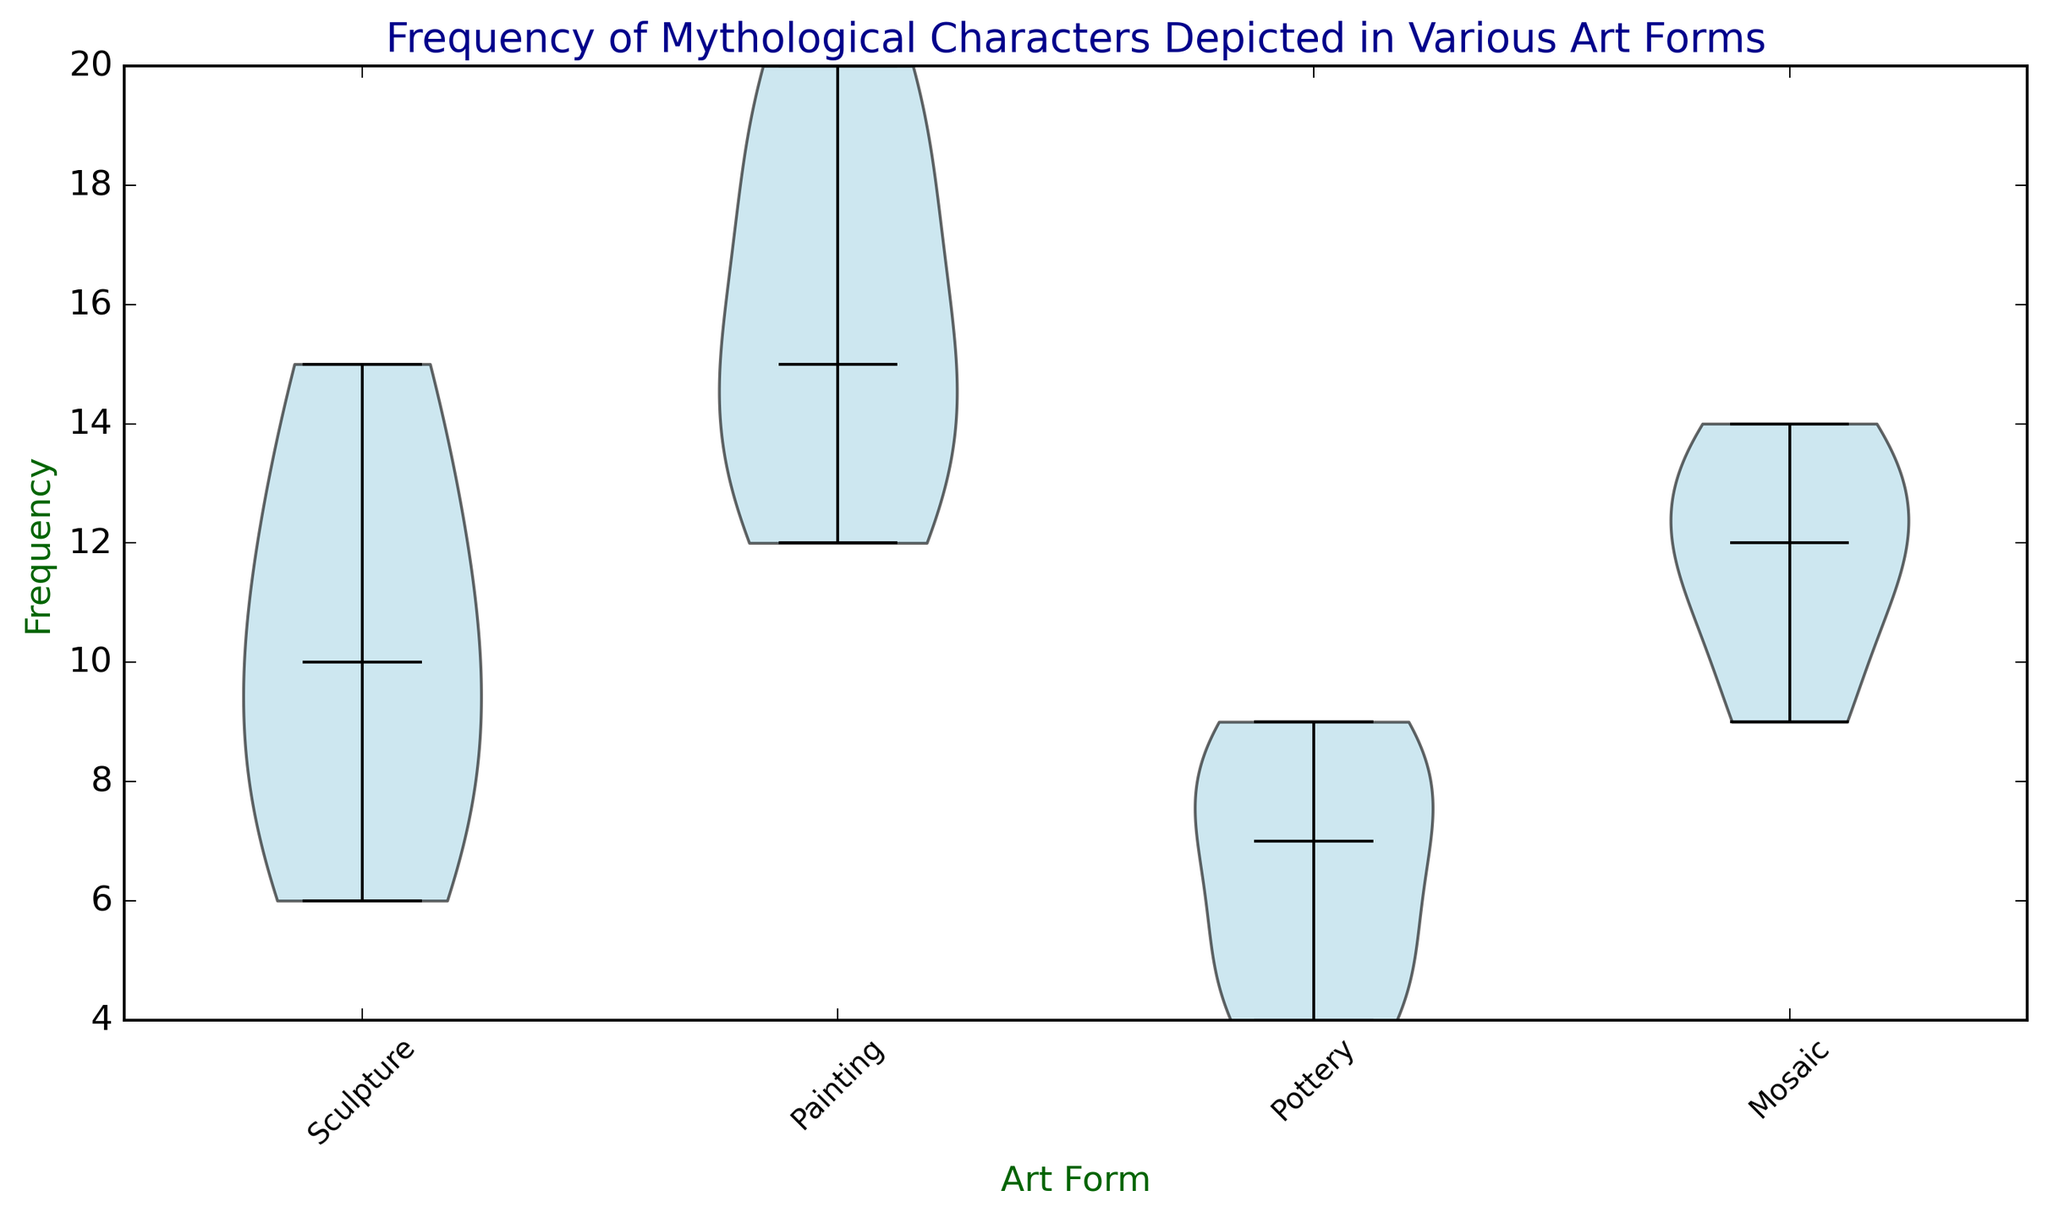What's the median frequency of mythological characters depicted in sculptures? The median value is shown by the horizontal line in the middle of the violin plot. For the 'Sculpture' category, the median frequency appears to be around 10.
Answer: 10 Which art form has the highest median frequency for depicting mythological characters? By comparing the median frequencies marked by the horizontal lines across all violin plots, 'Painting' has the highest median frequency.
Answer: Painting How does the spread of frequency distribution for 'Pottery' compare to 'Mosaic'? The width of the violin plots indicates the spread of frequency distribution. 'Mosaic' has a wider spread of frequencies compared to 'Pottery', indicating more variability in the frequency of mythological characters depicted.
Answer: Mosaic has a wider spread Which art form shows the lowest frequency of mythological characters and what is that frequency? By observing the bottoms of the violin plots, 'Pottery' shows the lowest frequency, which is around 4.
Answer: Pottery, 4 In which art form is the frequency of mythological characters most tightly clustered around the median? A narrower violin plot indicates a tighter clustering around the median. 'Pottery' shows the most tightly clustered distribution around its median.
Answer: Pottery Calculate the difference between the maximum frequencies depicted in 'Sculpture' and 'Painting'. The maximum frequency in 'Sculpture' is around 15, and in 'Painting', it is 20. The difference is 20 - 15 = 5.
Answer: 5 What visual attribute indicates the median in the violin plots? The median is represented by the horizontal line inside each violin plot.
Answer: Horizontal line Which art form has the greatest range of frequency for mythological characters? The range can be inferred from the heights of the violin plots. 'Painting' has the tallest plot, indicating the greatest range.
Answer: Painting What is the most frequent depiction in the 'Mosaic' art form? By looking at the top of the violin plot, the most frequent depiction in 'Mosaic' is around 14.
Answer: 14 